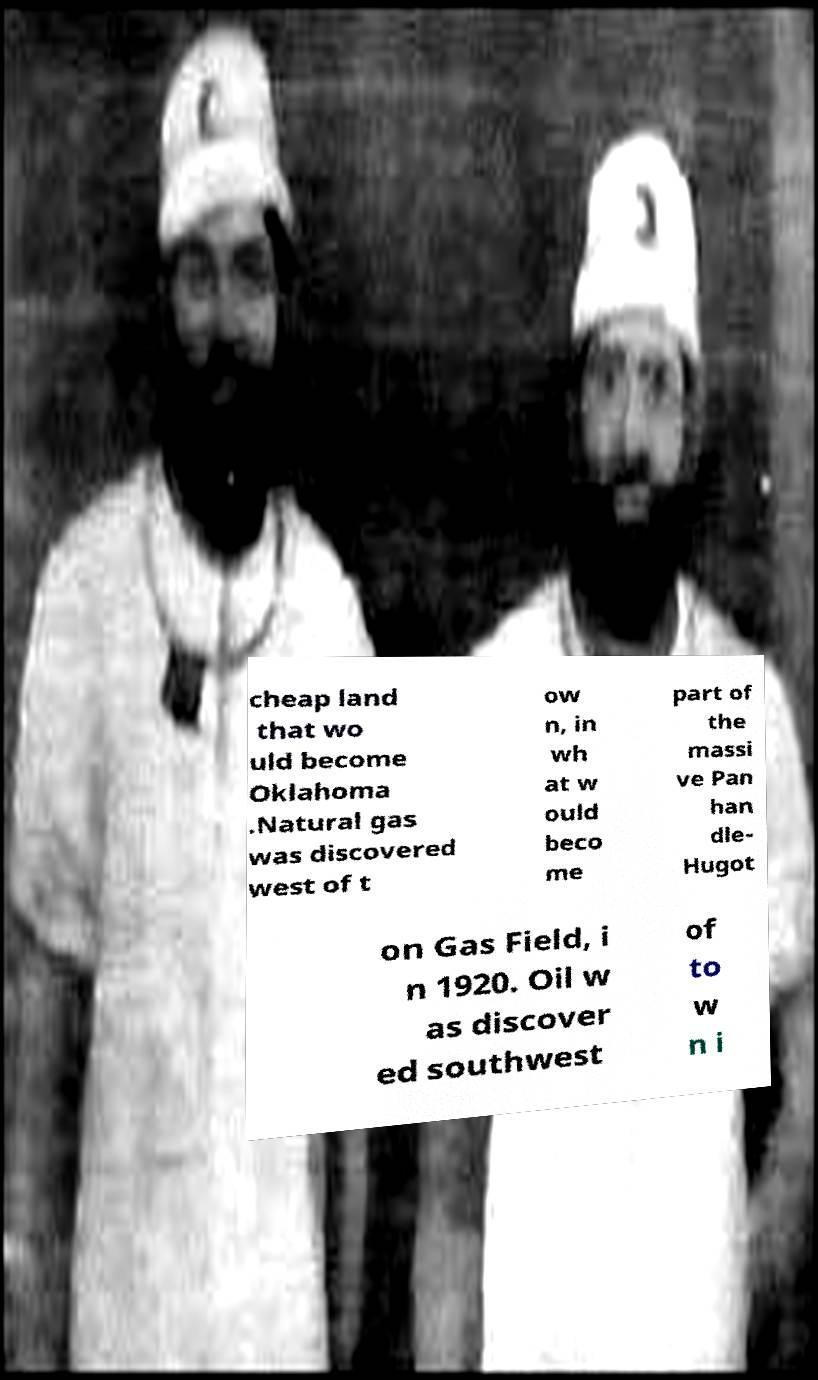Please read and relay the text visible in this image. What does it say? cheap land that wo uld become Oklahoma .Natural gas was discovered west of t ow n, in wh at w ould beco me part of the massi ve Pan han dle- Hugot on Gas Field, i n 1920. Oil w as discover ed southwest of to w n i 